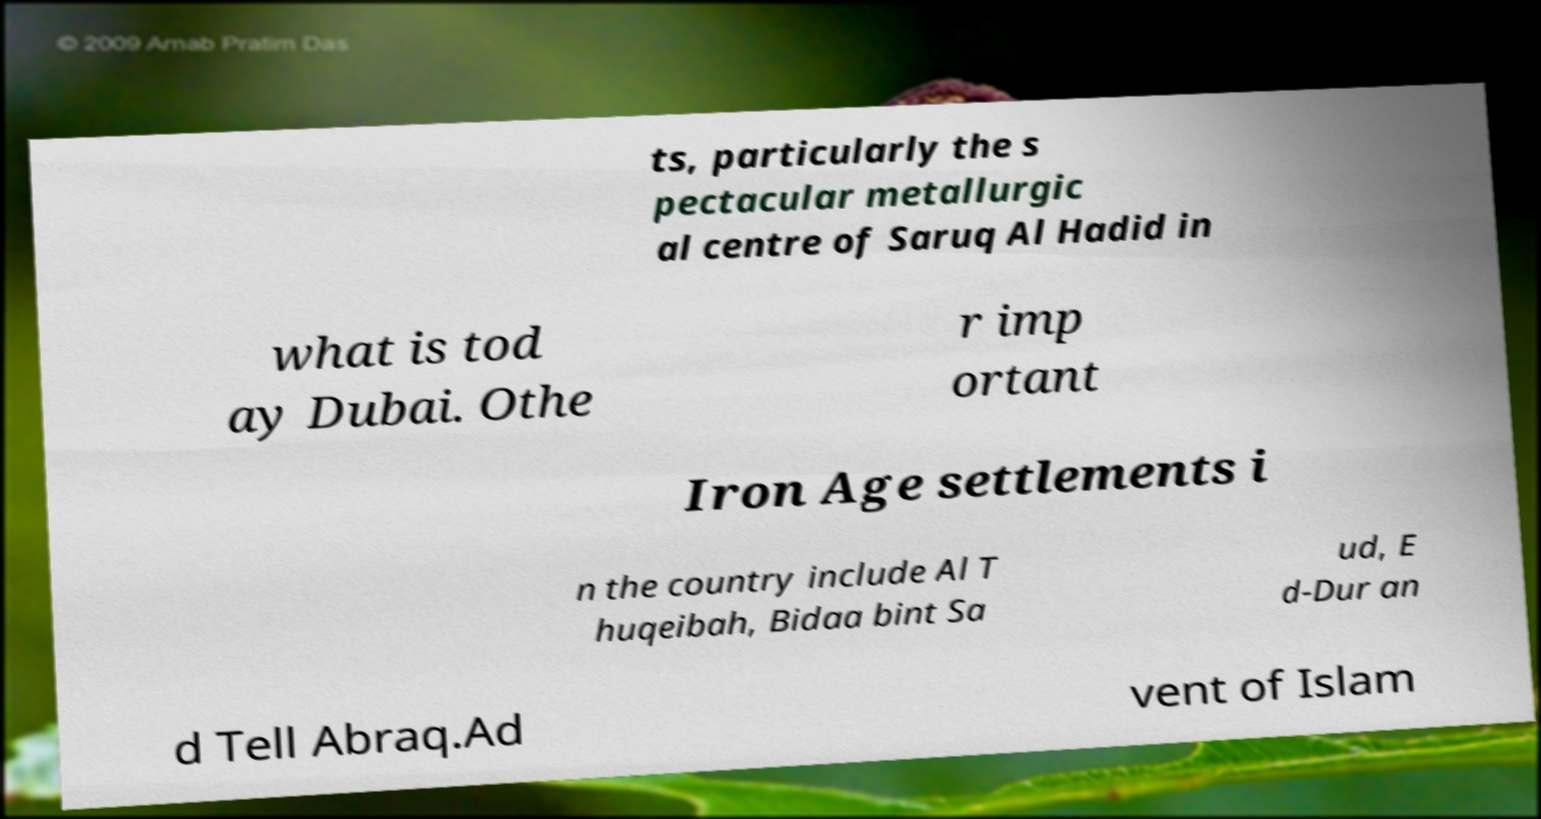I need the written content from this picture converted into text. Can you do that? ts, particularly the s pectacular metallurgic al centre of Saruq Al Hadid in what is tod ay Dubai. Othe r imp ortant Iron Age settlements i n the country include Al T huqeibah, Bidaa bint Sa ud, E d-Dur an d Tell Abraq.Ad vent of Islam 